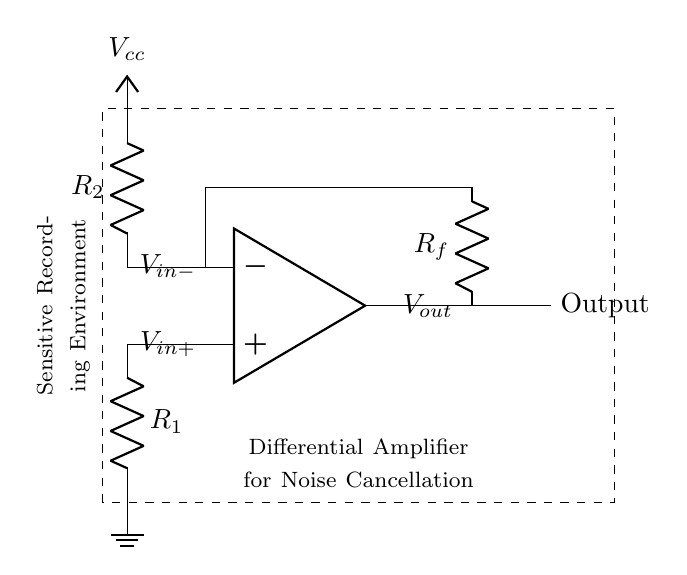What are the two input voltages for this amplifier? The two input voltages are denoted as V_in+ and V_in-. They are labeled on the circuit diagram next to the corresponding op-amp pins.
Answer: V_in+ and V_in- What is the function of resistor R_1? Resistor R_1 is connected to V_in+ and ungrounded, indicating it plays a role in the differential input phase of the amplifier, affecting the gain and input impedance of the circuit.
Answer: Input phase What is the output voltage labeled as? The output voltage is labeled as V_out, which is shown on the right side of the operational amplifier symbol.
Answer: V_out What is the power supply voltage for the negative input? The negative input is connected to V_cc, which serves as the positive power supply for the op-amp while the ground represents zero volts. Therefore, for the negative side, V_cc acts as the reference voltage.
Answer: V_cc How does this differential amplifier help in noise cancellation? A differential amplifier cancels noise by amplifying the difference between V_in+ and V_in-, while common-mode noise (which affects both inputs equally) is suppressed, making it ideal for sensitive recording environments.
Answer: Cancels noise What is the purpose of resistor R_f? Resistor R_f is connected from the output to the inverting input, creating negative feedback which stabilizes the output and sets the gain of the amplifier based on the relationship between R_f and R_2.
Answer: Negative feedback 